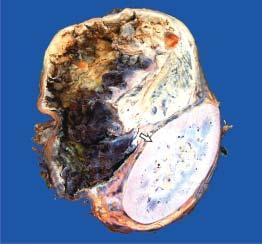do b, h&e show dark brown, necrotic and haemorrhagic tumour?
Answer the question using a single word or phrase. No 